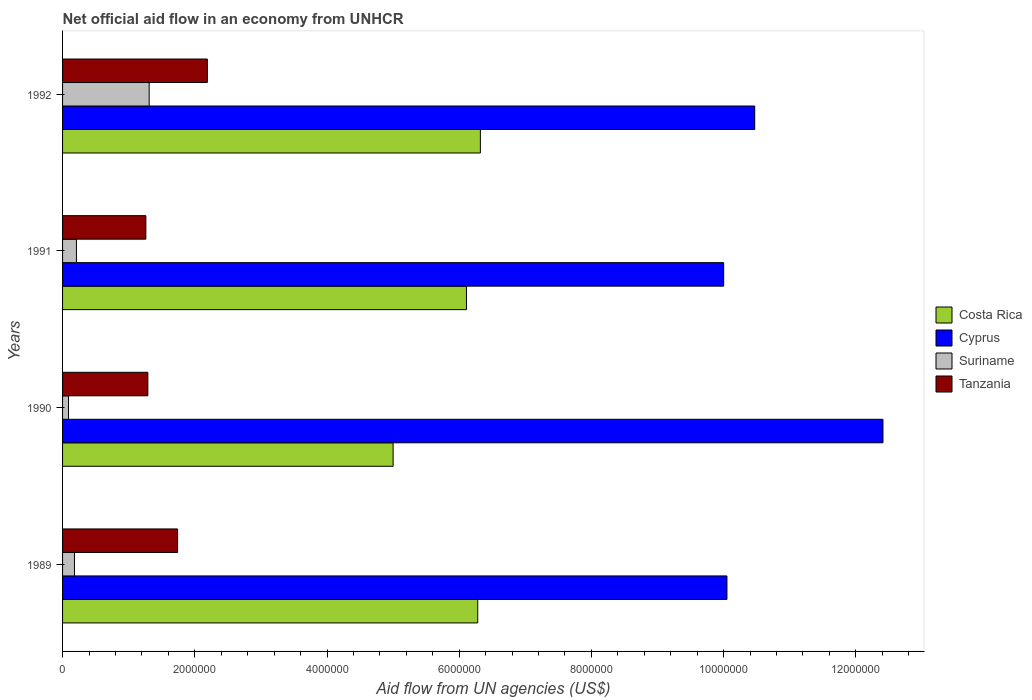How many different coloured bars are there?
Keep it short and to the point. 4. How many bars are there on the 3rd tick from the bottom?
Your answer should be very brief. 4. What is the label of the 3rd group of bars from the top?
Your answer should be very brief. 1990. What is the net official aid flow in Costa Rica in 1991?
Give a very brief answer. 6.11e+06. Across all years, what is the maximum net official aid flow in Tanzania?
Give a very brief answer. 2.19e+06. Across all years, what is the minimum net official aid flow in Tanzania?
Give a very brief answer. 1.26e+06. In which year was the net official aid flow in Cyprus maximum?
Your response must be concise. 1990. In which year was the net official aid flow in Costa Rica minimum?
Make the answer very short. 1990. What is the total net official aid flow in Tanzania in the graph?
Ensure brevity in your answer.  6.48e+06. What is the difference between the net official aid flow in Costa Rica in 1989 and that in 1990?
Offer a very short reply. 1.28e+06. What is the difference between the net official aid flow in Cyprus in 1990 and the net official aid flow in Suriname in 1989?
Your answer should be very brief. 1.22e+07. What is the average net official aid flow in Cyprus per year?
Provide a short and direct response. 1.07e+07. In the year 1989, what is the difference between the net official aid flow in Tanzania and net official aid flow in Cyprus?
Your answer should be very brief. -8.31e+06. What is the ratio of the net official aid flow in Suriname in 1990 to that in 1992?
Your response must be concise. 0.07. Is the difference between the net official aid flow in Tanzania in 1989 and 1990 greater than the difference between the net official aid flow in Cyprus in 1989 and 1990?
Provide a short and direct response. Yes. What is the difference between the highest and the lowest net official aid flow in Costa Rica?
Offer a very short reply. 1.32e+06. Is the sum of the net official aid flow in Cyprus in 1990 and 1992 greater than the maximum net official aid flow in Tanzania across all years?
Your response must be concise. Yes. Is it the case that in every year, the sum of the net official aid flow in Costa Rica and net official aid flow in Cyprus is greater than the sum of net official aid flow in Suriname and net official aid flow in Tanzania?
Give a very brief answer. No. What does the 3rd bar from the top in 1991 represents?
Keep it short and to the point. Cyprus. What does the 2nd bar from the bottom in 1990 represents?
Offer a terse response. Cyprus. How many years are there in the graph?
Keep it short and to the point. 4. What is the difference between two consecutive major ticks on the X-axis?
Your answer should be compact. 2.00e+06. Does the graph contain grids?
Give a very brief answer. No. What is the title of the graph?
Make the answer very short. Net official aid flow in an economy from UNHCR. What is the label or title of the X-axis?
Offer a terse response. Aid flow from UN agencies (US$). What is the label or title of the Y-axis?
Make the answer very short. Years. What is the Aid flow from UN agencies (US$) in Costa Rica in 1989?
Make the answer very short. 6.28e+06. What is the Aid flow from UN agencies (US$) in Cyprus in 1989?
Offer a very short reply. 1.00e+07. What is the Aid flow from UN agencies (US$) in Tanzania in 1989?
Your response must be concise. 1.74e+06. What is the Aid flow from UN agencies (US$) in Cyprus in 1990?
Offer a terse response. 1.24e+07. What is the Aid flow from UN agencies (US$) in Suriname in 1990?
Your answer should be very brief. 9.00e+04. What is the Aid flow from UN agencies (US$) of Tanzania in 1990?
Provide a succinct answer. 1.29e+06. What is the Aid flow from UN agencies (US$) of Costa Rica in 1991?
Your answer should be very brief. 6.11e+06. What is the Aid flow from UN agencies (US$) in Suriname in 1991?
Your answer should be very brief. 2.10e+05. What is the Aid flow from UN agencies (US$) in Tanzania in 1991?
Provide a short and direct response. 1.26e+06. What is the Aid flow from UN agencies (US$) in Costa Rica in 1992?
Your answer should be very brief. 6.32e+06. What is the Aid flow from UN agencies (US$) in Cyprus in 1992?
Your answer should be very brief. 1.05e+07. What is the Aid flow from UN agencies (US$) of Suriname in 1992?
Offer a very short reply. 1.31e+06. What is the Aid flow from UN agencies (US$) of Tanzania in 1992?
Provide a short and direct response. 2.19e+06. Across all years, what is the maximum Aid flow from UN agencies (US$) in Costa Rica?
Your response must be concise. 6.32e+06. Across all years, what is the maximum Aid flow from UN agencies (US$) of Cyprus?
Your answer should be very brief. 1.24e+07. Across all years, what is the maximum Aid flow from UN agencies (US$) in Suriname?
Keep it short and to the point. 1.31e+06. Across all years, what is the maximum Aid flow from UN agencies (US$) in Tanzania?
Keep it short and to the point. 2.19e+06. Across all years, what is the minimum Aid flow from UN agencies (US$) of Suriname?
Give a very brief answer. 9.00e+04. Across all years, what is the minimum Aid flow from UN agencies (US$) of Tanzania?
Give a very brief answer. 1.26e+06. What is the total Aid flow from UN agencies (US$) in Costa Rica in the graph?
Make the answer very short. 2.37e+07. What is the total Aid flow from UN agencies (US$) in Cyprus in the graph?
Your response must be concise. 4.29e+07. What is the total Aid flow from UN agencies (US$) of Suriname in the graph?
Provide a succinct answer. 1.79e+06. What is the total Aid flow from UN agencies (US$) in Tanzania in the graph?
Keep it short and to the point. 6.48e+06. What is the difference between the Aid flow from UN agencies (US$) in Costa Rica in 1989 and that in 1990?
Your answer should be compact. 1.28e+06. What is the difference between the Aid flow from UN agencies (US$) in Cyprus in 1989 and that in 1990?
Offer a very short reply. -2.36e+06. What is the difference between the Aid flow from UN agencies (US$) of Tanzania in 1989 and that in 1990?
Your response must be concise. 4.50e+05. What is the difference between the Aid flow from UN agencies (US$) of Costa Rica in 1989 and that in 1991?
Offer a very short reply. 1.70e+05. What is the difference between the Aid flow from UN agencies (US$) of Cyprus in 1989 and that in 1991?
Provide a succinct answer. 5.00e+04. What is the difference between the Aid flow from UN agencies (US$) of Suriname in 1989 and that in 1991?
Offer a terse response. -3.00e+04. What is the difference between the Aid flow from UN agencies (US$) of Costa Rica in 1989 and that in 1992?
Keep it short and to the point. -4.00e+04. What is the difference between the Aid flow from UN agencies (US$) of Cyprus in 1989 and that in 1992?
Ensure brevity in your answer.  -4.20e+05. What is the difference between the Aid flow from UN agencies (US$) in Suriname in 1989 and that in 1992?
Give a very brief answer. -1.13e+06. What is the difference between the Aid flow from UN agencies (US$) in Tanzania in 1989 and that in 1992?
Keep it short and to the point. -4.50e+05. What is the difference between the Aid flow from UN agencies (US$) of Costa Rica in 1990 and that in 1991?
Your response must be concise. -1.11e+06. What is the difference between the Aid flow from UN agencies (US$) of Cyprus in 1990 and that in 1991?
Give a very brief answer. 2.41e+06. What is the difference between the Aid flow from UN agencies (US$) in Costa Rica in 1990 and that in 1992?
Your answer should be compact. -1.32e+06. What is the difference between the Aid flow from UN agencies (US$) in Cyprus in 1990 and that in 1992?
Give a very brief answer. 1.94e+06. What is the difference between the Aid flow from UN agencies (US$) of Suriname in 1990 and that in 1992?
Make the answer very short. -1.22e+06. What is the difference between the Aid flow from UN agencies (US$) of Tanzania in 1990 and that in 1992?
Provide a succinct answer. -9.00e+05. What is the difference between the Aid flow from UN agencies (US$) of Costa Rica in 1991 and that in 1992?
Your answer should be compact. -2.10e+05. What is the difference between the Aid flow from UN agencies (US$) of Cyprus in 1991 and that in 1992?
Provide a succinct answer. -4.70e+05. What is the difference between the Aid flow from UN agencies (US$) in Suriname in 1991 and that in 1992?
Make the answer very short. -1.10e+06. What is the difference between the Aid flow from UN agencies (US$) of Tanzania in 1991 and that in 1992?
Give a very brief answer. -9.30e+05. What is the difference between the Aid flow from UN agencies (US$) of Costa Rica in 1989 and the Aid flow from UN agencies (US$) of Cyprus in 1990?
Make the answer very short. -6.13e+06. What is the difference between the Aid flow from UN agencies (US$) of Costa Rica in 1989 and the Aid flow from UN agencies (US$) of Suriname in 1990?
Provide a short and direct response. 6.19e+06. What is the difference between the Aid flow from UN agencies (US$) of Costa Rica in 1989 and the Aid flow from UN agencies (US$) of Tanzania in 1990?
Provide a short and direct response. 4.99e+06. What is the difference between the Aid flow from UN agencies (US$) of Cyprus in 1989 and the Aid flow from UN agencies (US$) of Suriname in 1990?
Provide a short and direct response. 9.96e+06. What is the difference between the Aid flow from UN agencies (US$) of Cyprus in 1989 and the Aid flow from UN agencies (US$) of Tanzania in 1990?
Give a very brief answer. 8.76e+06. What is the difference between the Aid flow from UN agencies (US$) in Suriname in 1989 and the Aid flow from UN agencies (US$) in Tanzania in 1990?
Give a very brief answer. -1.11e+06. What is the difference between the Aid flow from UN agencies (US$) in Costa Rica in 1989 and the Aid flow from UN agencies (US$) in Cyprus in 1991?
Your answer should be compact. -3.72e+06. What is the difference between the Aid flow from UN agencies (US$) in Costa Rica in 1989 and the Aid flow from UN agencies (US$) in Suriname in 1991?
Ensure brevity in your answer.  6.07e+06. What is the difference between the Aid flow from UN agencies (US$) in Costa Rica in 1989 and the Aid flow from UN agencies (US$) in Tanzania in 1991?
Your response must be concise. 5.02e+06. What is the difference between the Aid flow from UN agencies (US$) in Cyprus in 1989 and the Aid flow from UN agencies (US$) in Suriname in 1991?
Your answer should be very brief. 9.84e+06. What is the difference between the Aid flow from UN agencies (US$) in Cyprus in 1989 and the Aid flow from UN agencies (US$) in Tanzania in 1991?
Your response must be concise. 8.79e+06. What is the difference between the Aid flow from UN agencies (US$) in Suriname in 1989 and the Aid flow from UN agencies (US$) in Tanzania in 1991?
Offer a very short reply. -1.08e+06. What is the difference between the Aid flow from UN agencies (US$) of Costa Rica in 1989 and the Aid flow from UN agencies (US$) of Cyprus in 1992?
Offer a terse response. -4.19e+06. What is the difference between the Aid flow from UN agencies (US$) in Costa Rica in 1989 and the Aid flow from UN agencies (US$) in Suriname in 1992?
Your response must be concise. 4.97e+06. What is the difference between the Aid flow from UN agencies (US$) in Costa Rica in 1989 and the Aid flow from UN agencies (US$) in Tanzania in 1992?
Keep it short and to the point. 4.09e+06. What is the difference between the Aid flow from UN agencies (US$) of Cyprus in 1989 and the Aid flow from UN agencies (US$) of Suriname in 1992?
Offer a very short reply. 8.74e+06. What is the difference between the Aid flow from UN agencies (US$) in Cyprus in 1989 and the Aid flow from UN agencies (US$) in Tanzania in 1992?
Offer a terse response. 7.86e+06. What is the difference between the Aid flow from UN agencies (US$) of Suriname in 1989 and the Aid flow from UN agencies (US$) of Tanzania in 1992?
Make the answer very short. -2.01e+06. What is the difference between the Aid flow from UN agencies (US$) of Costa Rica in 1990 and the Aid flow from UN agencies (US$) of Cyprus in 1991?
Your answer should be compact. -5.00e+06. What is the difference between the Aid flow from UN agencies (US$) in Costa Rica in 1990 and the Aid flow from UN agencies (US$) in Suriname in 1991?
Offer a terse response. 4.79e+06. What is the difference between the Aid flow from UN agencies (US$) of Costa Rica in 1990 and the Aid flow from UN agencies (US$) of Tanzania in 1991?
Offer a very short reply. 3.74e+06. What is the difference between the Aid flow from UN agencies (US$) of Cyprus in 1990 and the Aid flow from UN agencies (US$) of Suriname in 1991?
Ensure brevity in your answer.  1.22e+07. What is the difference between the Aid flow from UN agencies (US$) in Cyprus in 1990 and the Aid flow from UN agencies (US$) in Tanzania in 1991?
Provide a short and direct response. 1.12e+07. What is the difference between the Aid flow from UN agencies (US$) in Suriname in 1990 and the Aid flow from UN agencies (US$) in Tanzania in 1991?
Your answer should be very brief. -1.17e+06. What is the difference between the Aid flow from UN agencies (US$) in Costa Rica in 1990 and the Aid flow from UN agencies (US$) in Cyprus in 1992?
Your answer should be very brief. -5.47e+06. What is the difference between the Aid flow from UN agencies (US$) of Costa Rica in 1990 and the Aid flow from UN agencies (US$) of Suriname in 1992?
Make the answer very short. 3.69e+06. What is the difference between the Aid flow from UN agencies (US$) of Costa Rica in 1990 and the Aid flow from UN agencies (US$) of Tanzania in 1992?
Keep it short and to the point. 2.81e+06. What is the difference between the Aid flow from UN agencies (US$) of Cyprus in 1990 and the Aid flow from UN agencies (US$) of Suriname in 1992?
Your response must be concise. 1.11e+07. What is the difference between the Aid flow from UN agencies (US$) in Cyprus in 1990 and the Aid flow from UN agencies (US$) in Tanzania in 1992?
Offer a very short reply. 1.02e+07. What is the difference between the Aid flow from UN agencies (US$) in Suriname in 1990 and the Aid flow from UN agencies (US$) in Tanzania in 1992?
Your answer should be very brief. -2.10e+06. What is the difference between the Aid flow from UN agencies (US$) in Costa Rica in 1991 and the Aid flow from UN agencies (US$) in Cyprus in 1992?
Your response must be concise. -4.36e+06. What is the difference between the Aid flow from UN agencies (US$) of Costa Rica in 1991 and the Aid flow from UN agencies (US$) of Suriname in 1992?
Keep it short and to the point. 4.80e+06. What is the difference between the Aid flow from UN agencies (US$) of Costa Rica in 1991 and the Aid flow from UN agencies (US$) of Tanzania in 1992?
Offer a very short reply. 3.92e+06. What is the difference between the Aid flow from UN agencies (US$) in Cyprus in 1991 and the Aid flow from UN agencies (US$) in Suriname in 1992?
Your answer should be very brief. 8.69e+06. What is the difference between the Aid flow from UN agencies (US$) in Cyprus in 1991 and the Aid flow from UN agencies (US$) in Tanzania in 1992?
Keep it short and to the point. 7.81e+06. What is the difference between the Aid flow from UN agencies (US$) in Suriname in 1991 and the Aid flow from UN agencies (US$) in Tanzania in 1992?
Offer a terse response. -1.98e+06. What is the average Aid flow from UN agencies (US$) in Costa Rica per year?
Keep it short and to the point. 5.93e+06. What is the average Aid flow from UN agencies (US$) of Cyprus per year?
Make the answer very short. 1.07e+07. What is the average Aid flow from UN agencies (US$) in Suriname per year?
Offer a terse response. 4.48e+05. What is the average Aid flow from UN agencies (US$) in Tanzania per year?
Offer a very short reply. 1.62e+06. In the year 1989, what is the difference between the Aid flow from UN agencies (US$) in Costa Rica and Aid flow from UN agencies (US$) in Cyprus?
Provide a succinct answer. -3.77e+06. In the year 1989, what is the difference between the Aid flow from UN agencies (US$) of Costa Rica and Aid flow from UN agencies (US$) of Suriname?
Your answer should be compact. 6.10e+06. In the year 1989, what is the difference between the Aid flow from UN agencies (US$) of Costa Rica and Aid flow from UN agencies (US$) of Tanzania?
Your response must be concise. 4.54e+06. In the year 1989, what is the difference between the Aid flow from UN agencies (US$) of Cyprus and Aid flow from UN agencies (US$) of Suriname?
Offer a very short reply. 9.87e+06. In the year 1989, what is the difference between the Aid flow from UN agencies (US$) of Cyprus and Aid flow from UN agencies (US$) of Tanzania?
Offer a terse response. 8.31e+06. In the year 1989, what is the difference between the Aid flow from UN agencies (US$) in Suriname and Aid flow from UN agencies (US$) in Tanzania?
Make the answer very short. -1.56e+06. In the year 1990, what is the difference between the Aid flow from UN agencies (US$) in Costa Rica and Aid flow from UN agencies (US$) in Cyprus?
Ensure brevity in your answer.  -7.41e+06. In the year 1990, what is the difference between the Aid flow from UN agencies (US$) of Costa Rica and Aid flow from UN agencies (US$) of Suriname?
Make the answer very short. 4.91e+06. In the year 1990, what is the difference between the Aid flow from UN agencies (US$) of Costa Rica and Aid flow from UN agencies (US$) of Tanzania?
Make the answer very short. 3.71e+06. In the year 1990, what is the difference between the Aid flow from UN agencies (US$) in Cyprus and Aid flow from UN agencies (US$) in Suriname?
Your answer should be compact. 1.23e+07. In the year 1990, what is the difference between the Aid flow from UN agencies (US$) of Cyprus and Aid flow from UN agencies (US$) of Tanzania?
Your answer should be compact. 1.11e+07. In the year 1990, what is the difference between the Aid flow from UN agencies (US$) in Suriname and Aid flow from UN agencies (US$) in Tanzania?
Provide a short and direct response. -1.20e+06. In the year 1991, what is the difference between the Aid flow from UN agencies (US$) in Costa Rica and Aid flow from UN agencies (US$) in Cyprus?
Keep it short and to the point. -3.89e+06. In the year 1991, what is the difference between the Aid flow from UN agencies (US$) in Costa Rica and Aid flow from UN agencies (US$) in Suriname?
Provide a short and direct response. 5.90e+06. In the year 1991, what is the difference between the Aid flow from UN agencies (US$) in Costa Rica and Aid flow from UN agencies (US$) in Tanzania?
Give a very brief answer. 4.85e+06. In the year 1991, what is the difference between the Aid flow from UN agencies (US$) of Cyprus and Aid flow from UN agencies (US$) of Suriname?
Give a very brief answer. 9.79e+06. In the year 1991, what is the difference between the Aid flow from UN agencies (US$) of Cyprus and Aid flow from UN agencies (US$) of Tanzania?
Your response must be concise. 8.74e+06. In the year 1991, what is the difference between the Aid flow from UN agencies (US$) of Suriname and Aid flow from UN agencies (US$) of Tanzania?
Give a very brief answer. -1.05e+06. In the year 1992, what is the difference between the Aid flow from UN agencies (US$) of Costa Rica and Aid flow from UN agencies (US$) of Cyprus?
Keep it short and to the point. -4.15e+06. In the year 1992, what is the difference between the Aid flow from UN agencies (US$) in Costa Rica and Aid flow from UN agencies (US$) in Suriname?
Ensure brevity in your answer.  5.01e+06. In the year 1992, what is the difference between the Aid flow from UN agencies (US$) in Costa Rica and Aid flow from UN agencies (US$) in Tanzania?
Provide a short and direct response. 4.13e+06. In the year 1992, what is the difference between the Aid flow from UN agencies (US$) in Cyprus and Aid flow from UN agencies (US$) in Suriname?
Provide a succinct answer. 9.16e+06. In the year 1992, what is the difference between the Aid flow from UN agencies (US$) in Cyprus and Aid flow from UN agencies (US$) in Tanzania?
Offer a terse response. 8.28e+06. In the year 1992, what is the difference between the Aid flow from UN agencies (US$) in Suriname and Aid flow from UN agencies (US$) in Tanzania?
Ensure brevity in your answer.  -8.80e+05. What is the ratio of the Aid flow from UN agencies (US$) in Costa Rica in 1989 to that in 1990?
Offer a terse response. 1.26. What is the ratio of the Aid flow from UN agencies (US$) in Cyprus in 1989 to that in 1990?
Offer a very short reply. 0.81. What is the ratio of the Aid flow from UN agencies (US$) in Tanzania in 1989 to that in 1990?
Offer a terse response. 1.35. What is the ratio of the Aid flow from UN agencies (US$) of Costa Rica in 1989 to that in 1991?
Offer a very short reply. 1.03. What is the ratio of the Aid flow from UN agencies (US$) in Cyprus in 1989 to that in 1991?
Keep it short and to the point. 1. What is the ratio of the Aid flow from UN agencies (US$) in Tanzania in 1989 to that in 1991?
Ensure brevity in your answer.  1.38. What is the ratio of the Aid flow from UN agencies (US$) of Costa Rica in 1989 to that in 1992?
Your response must be concise. 0.99. What is the ratio of the Aid flow from UN agencies (US$) of Cyprus in 1989 to that in 1992?
Ensure brevity in your answer.  0.96. What is the ratio of the Aid flow from UN agencies (US$) in Suriname in 1989 to that in 1992?
Your answer should be compact. 0.14. What is the ratio of the Aid flow from UN agencies (US$) in Tanzania in 1989 to that in 1992?
Provide a short and direct response. 0.79. What is the ratio of the Aid flow from UN agencies (US$) of Costa Rica in 1990 to that in 1991?
Ensure brevity in your answer.  0.82. What is the ratio of the Aid flow from UN agencies (US$) in Cyprus in 1990 to that in 1991?
Keep it short and to the point. 1.24. What is the ratio of the Aid flow from UN agencies (US$) of Suriname in 1990 to that in 1991?
Provide a short and direct response. 0.43. What is the ratio of the Aid flow from UN agencies (US$) of Tanzania in 1990 to that in 1991?
Offer a terse response. 1.02. What is the ratio of the Aid flow from UN agencies (US$) in Costa Rica in 1990 to that in 1992?
Ensure brevity in your answer.  0.79. What is the ratio of the Aid flow from UN agencies (US$) of Cyprus in 1990 to that in 1992?
Provide a succinct answer. 1.19. What is the ratio of the Aid flow from UN agencies (US$) in Suriname in 1990 to that in 1992?
Make the answer very short. 0.07. What is the ratio of the Aid flow from UN agencies (US$) of Tanzania in 1990 to that in 1992?
Make the answer very short. 0.59. What is the ratio of the Aid flow from UN agencies (US$) in Costa Rica in 1991 to that in 1992?
Offer a terse response. 0.97. What is the ratio of the Aid flow from UN agencies (US$) of Cyprus in 1991 to that in 1992?
Provide a short and direct response. 0.96. What is the ratio of the Aid flow from UN agencies (US$) in Suriname in 1991 to that in 1992?
Make the answer very short. 0.16. What is the ratio of the Aid flow from UN agencies (US$) of Tanzania in 1991 to that in 1992?
Make the answer very short. 0.58. What is the difference between the highest and the second highest Aid flow from UN agencies (US$) of Costa Rica?
Offer a very short reply. 4.00e+04. What is the difference between the highest and the second highest Aid flow from UN agencies (US$) in Cyprus?
Provide a succinct answer. 1.94e+06. What is the difference between the highest and the second highest Aid flow from UN agencies (US$) in Suriname?
Make the answer very short. 1.10e+06. What is the difference between the highest and the second highest Aid flow from UN agencies (US$) of Tanzania?
Provide a succinct answer. 4.50e+05. What is the difference between the highest and the lowest Aid flow from UN agencies (US$) of Costa Rica?
Give a very brief answer. 1.32e+06. What is the difference between the highest and the lowest Aid flow from UN agencies (US$) in Cyprus?
Make the answer very short. 2.41e+06. What is the difference between the highest and the lowest Aid flow from UN agencies (US$) in Suriname?
Your answer should be compact. 1.22e+06. What is the difference between the highest and the lowest Aid flow from UN agencies (US$) in Tanzania?
Ensure brevity in your answer.  9.30e+05. 